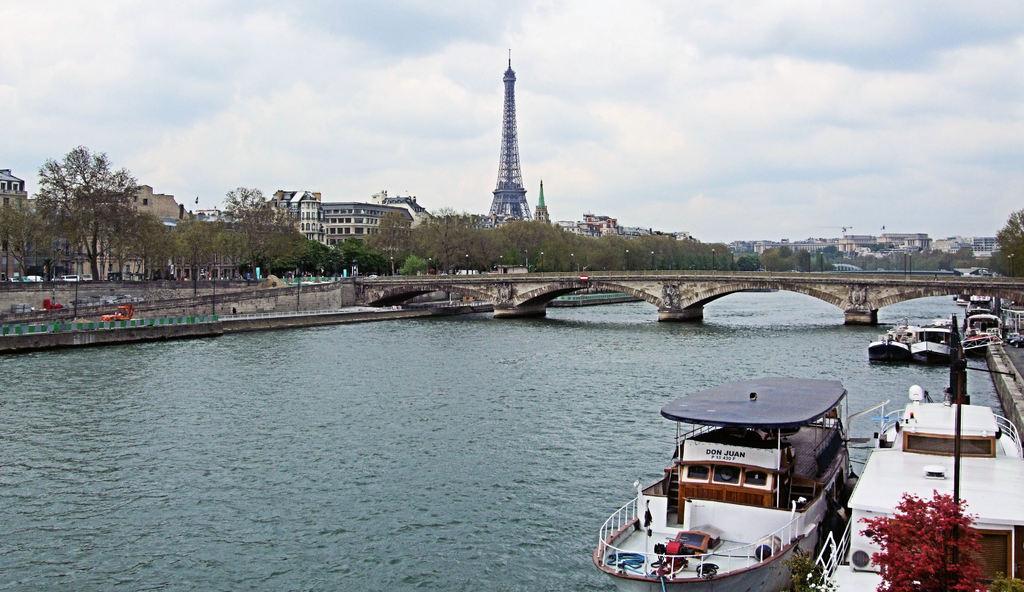Can you describe this image briefly? In the foreground of the picture there are boats, water body and bridge. In the middle of the picture there are trees, buildings, roads, vehicles, monuments and other objects. At the top it is sky. 